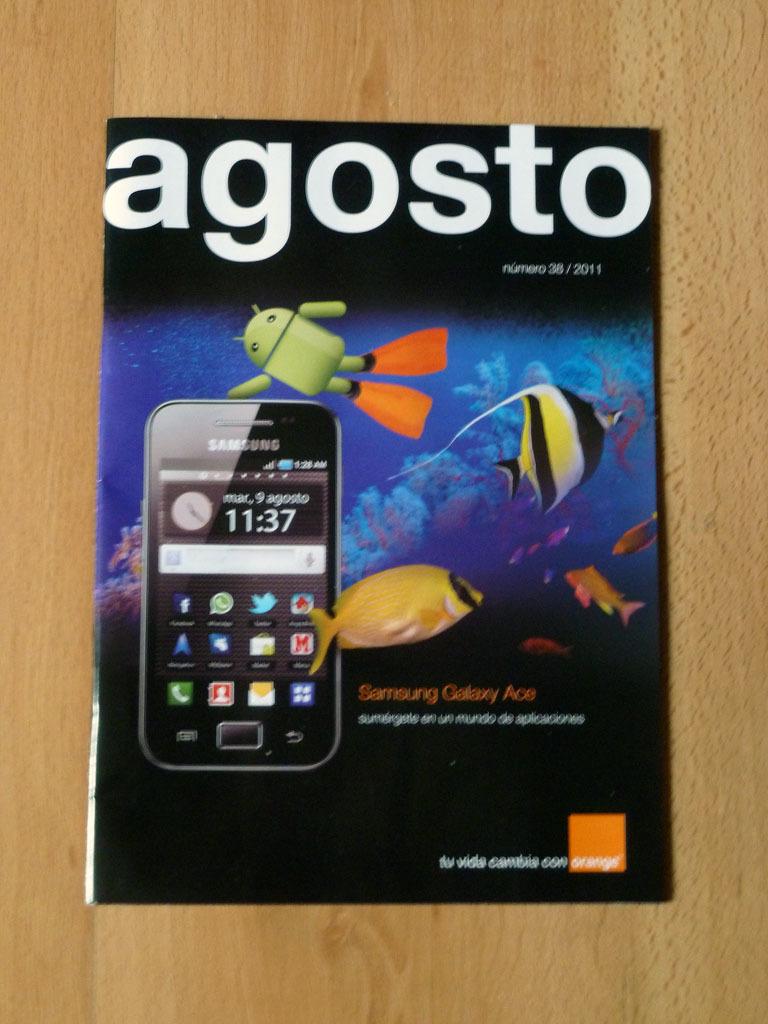What time does the phone show?
Provide a short and direct response. 11:37. What is the brand of the phone?
Provide a short and direct response. Samsung. 